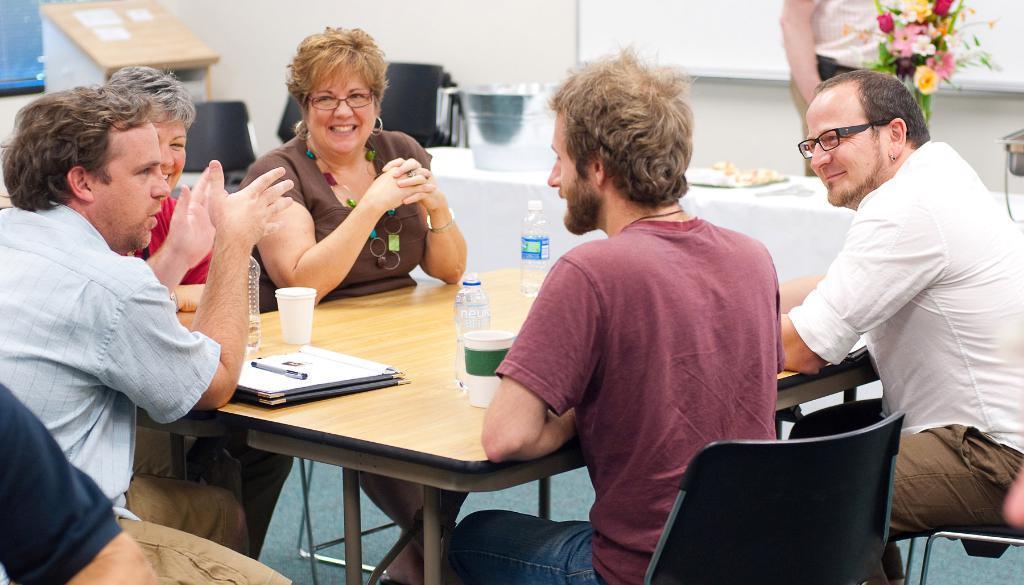Describe this image in one or two sentences. In this picture we can see a group of people sitting on chairs and in front of them on table we have bottles, glasses, books, pens and they are smiling where one is talking and in background we can see wall, chairs, podium, screen, flowers, some persons standing. 